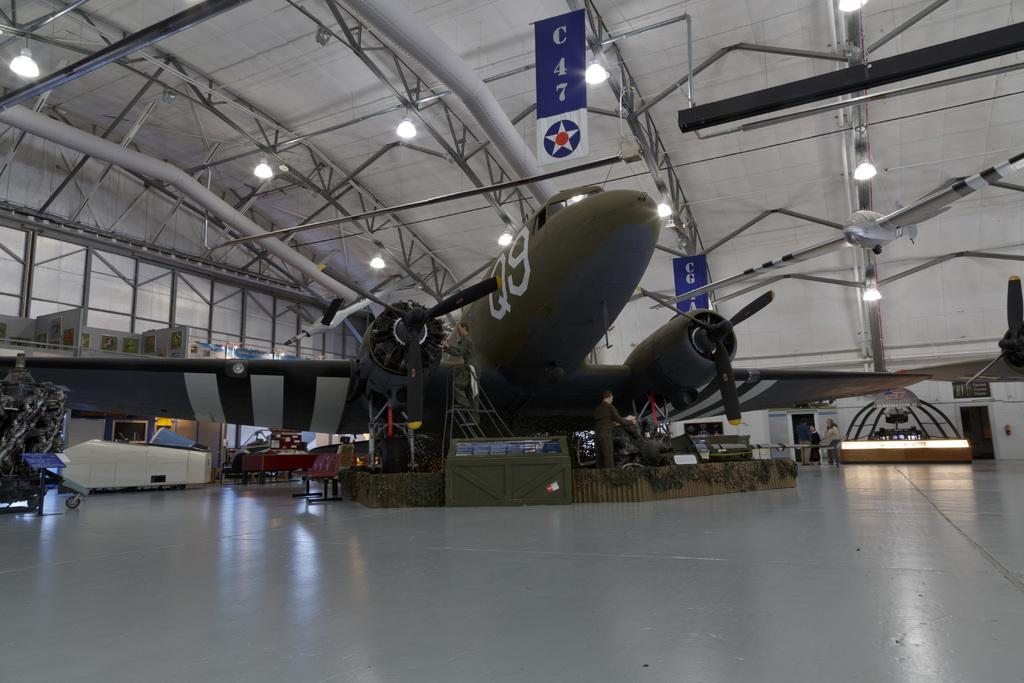<image>
Render a clear and concise summary of the photo. a airplane in a hangar under a sign reading C47 